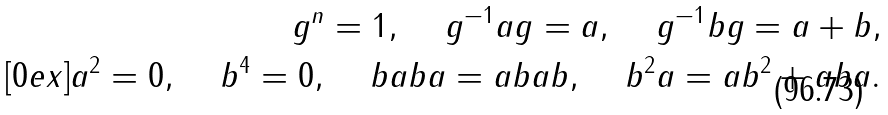<formula> <loc_0><loc_0><loc_500><loc_500>g ^ { n } = 1 , \quad \, g ^ { - 1 } a g = a , \quad \, g ^ { - 1 } b g = a + b , \\ [ 0 e x ] a ^ { 2 } = 0 , \quad \, b ^ { 4 } = 0 , \quad \, b a b a = a b a b , \quad \, b ^ { 2 } a = a b ^ { 2 } + a b a .</formula> 